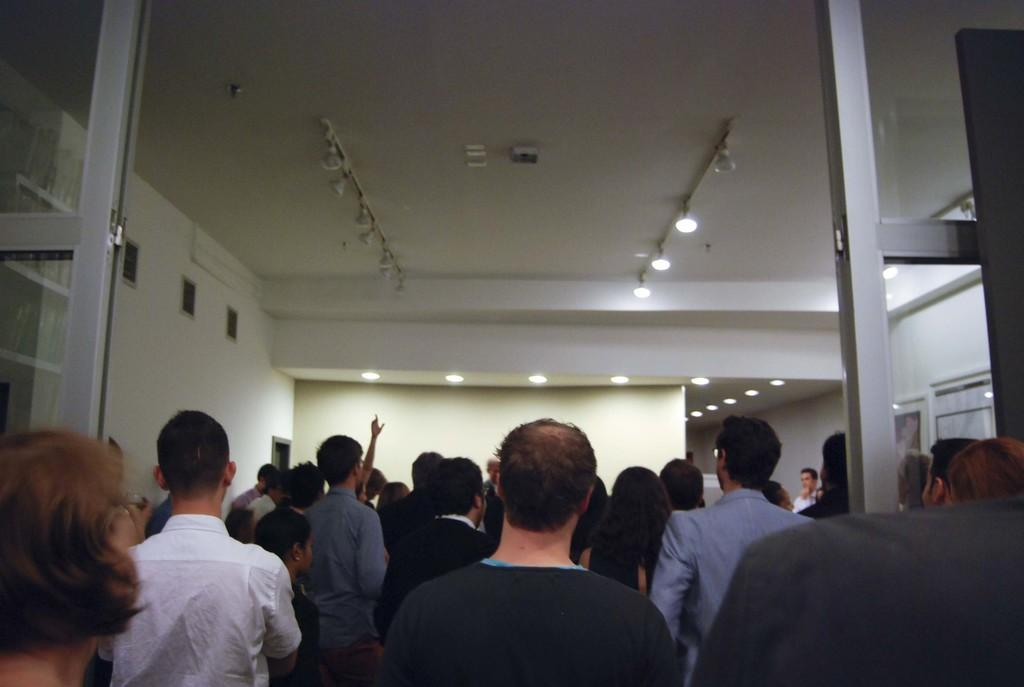How many people are in the image? There is a group of people in the image. What can be observed about the clothing of the people in the image? The people are wearing different color dresses. What is visible in the background of the image? There is a wall in the background of the image. What can be seen in the top of the image? There are many lights visible in the top of the image. What is present to the right of the image? There are frames present to the right of the image. What type of seat can be seen in the image? There is no seat present in the image. Can you describe the sail in the image? There is no sail present in the image. 